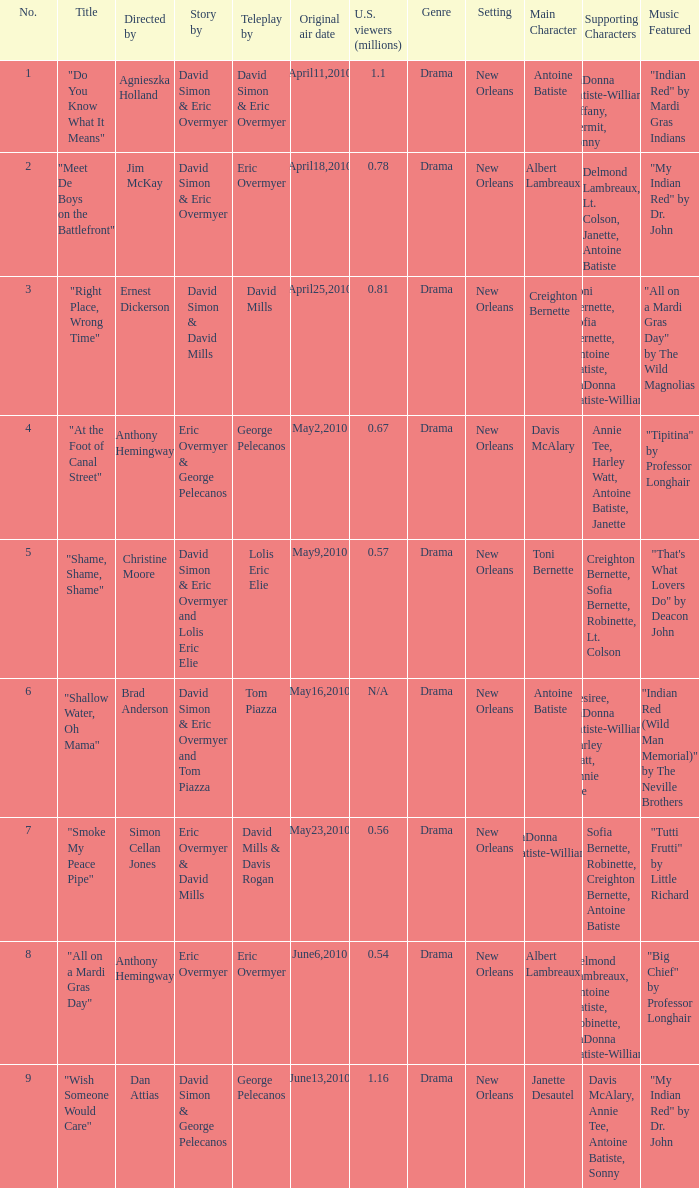Help me parse the entirety of this table. {'header': ['No.', 'Title', 'Directed by', 'Story by', 'Teleplay by', 'Original air date', 'U.S. viewers (millions)', 'Genre', 'Setting', 'Main Character', 'Supporting Characters', 'Music Featured'], 'rows': [['1', '"Do You Know What It Means"', 'Agnieszka Holland', 'David Simon & Eric Overmyer', 'David Simon & Eric Overmyer', 'April11,2010', '1.1', 'Drama', 'New Orleans', 'Antoine Batiste', 'LaDonna Batiste-Williams, Tiffany, Kermit, Sonny', '"Indian Red" by Mardi Gras Indians'], ['2', '"Meet De Boys on the Battlefront"', 'Jim McKay', 'David Simon & Eric Overmyer', 'Eric Overmyer', 'April18,2010', '0.78', 'Drama', 'New Orleans', 'Albert Lambreaux', 'Delmond Lambreaux, Lt. Colson, Janette, Antoine Batiste', '"My Indian Red" by Dr. John'], ['3', '"Right Place, Wrong Time"', 'Ernest Dickerson', 'David Simon & David Mills', 'David Mills', 'April25,2010', '0.81', 'Drama', 'New Orleans', 'Creighton Bernette', 'Toni Bernette, Sofia Bernette, Antoine Batiste, LaDonna Batiste-Williams', '"All on a Mardi Gras Day" by The Wild Magnolias'], ['4', '"At the Foot of Canal Street"', 'Anthony Hemingway', 'Eric Overmyer & George Pelecanos', 'George Pelecanos', 'May2,2010', '0.67', 'Drama', 'New Orleans', 'Davis McAlary', 'Annie Tee, Harley Watt, Antoine Batiste, Janette', '"Tipitina" by Professor Longhair'], ['5', '"Shame, Shame, Shame"', 'Christine Moore', 'David Simon & Eric Overmyer and Lolis Eric Elie', 'Lolis Eric Elie', 'May9,2010', '0.57', 'Drama', 'New Orleans', 'Toni Bernette', 'Creighton Bernette, Sofia Bernette, Robinette, Lt. Colson', '"That\'s What Lovers Do" by Deacon John'], ['6', '"Shallow Water, Oh Mama"', 'Brad Anderson', 'David Simon & Eric Overmyer and Tom Piazza', 'Tom Piazza', 'May16,2010', 'N/A', 'Drama', 'New Orleans', 'Antoine Batiste', 'Desiree, LaDonna Batiste-Williams, Harley Watt, Annie Tee', '"Indian Red (Wild Man Memorial)" by The Neville Brothers'], ['7', '"Smoke My Peace Pipe"', 'Simon Cellan Jones', 'Eric Overmyer & David Mills', 'David Mills & Davis Rogan', 'May23,2010', '0.56', 'Drama', 'New Orleans', 'LaDonna Batiste-Williams', 'Sofia Bernette, Robinette, Creighton Bernette, Antoine Batiste', '"Tutti Frutti" by Little Richard'], ['8', '"All on a Mardi Gras Day"', 'Anthony Hemingway', 'Eric Overmyer', 'Eric Overmyer', 'June6,2010', '0.54', 'Drama', 'New Orleans', 'Albert Lambreaux', 'Delmond Lambreaux, Antoine Batiste, Robinette, LaDonna Batiste-Williams', '"Big Chief" by Professor Longhair'], ['9', '"Wish Someone Would Care"', 'Dan Attias', 'David Simon & George Pelecanos', 'George Pelecanos', 'June13,2010', '1.16', 'Drama', 'New Orleans', 'Janette Desautel', 'Davis McAlary, Annie Tee, Antoine Batiste, Sonny', '"My Indian Red" by Dr. John']]} Name the number for simon cellan jones 7.0. 